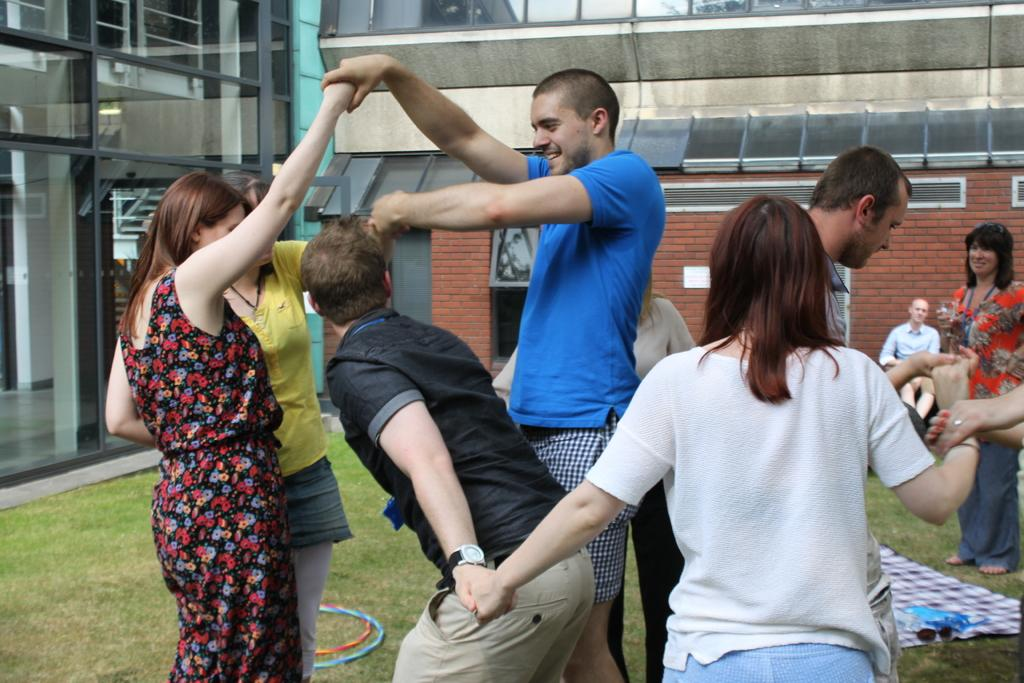What is the main subject of the image? The main subject of the image is a group of people. Where are the people located in the image? The people are standing on the grass in the image. What is behind the people in the image? The people are in front of a building in the image. How are the people interacting with each other in the image? The people are holding each other's hands in the image. What type of wrench can be seen in the hands of one of the people in the image? There is no wrench present in the image; the people are holding each other's hands. Can you tell me how many cows are grazing in the background of the image? There are no cows present in the image; the people are standing on the grass in front of a building. 